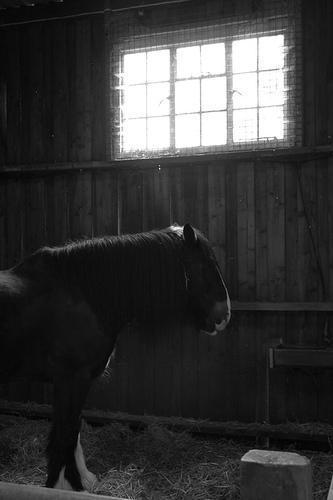How many kites are flying higher than higher than 10 feet?
Give a very brief answer. 0. 